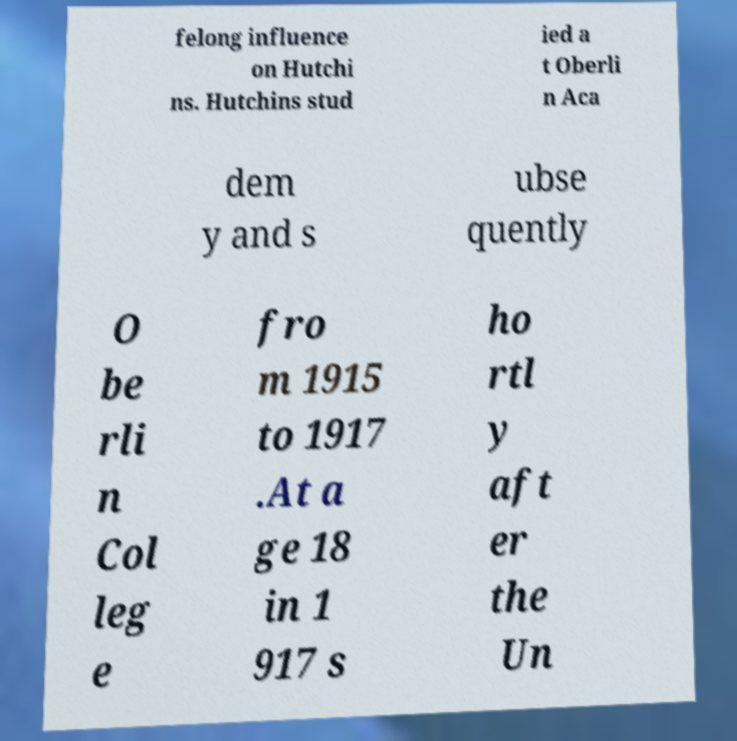Could you assist in decoding the text presented in this image and type it out clearly? felong influence on Hutchi ns. Hutchins stud ied a t Oberli n Aca dem y and s ubse quently O be rli n Col leg e fro m 1915 to 1917 .At a ge 18 in 1 917 s ho rtl y aft er the Un 